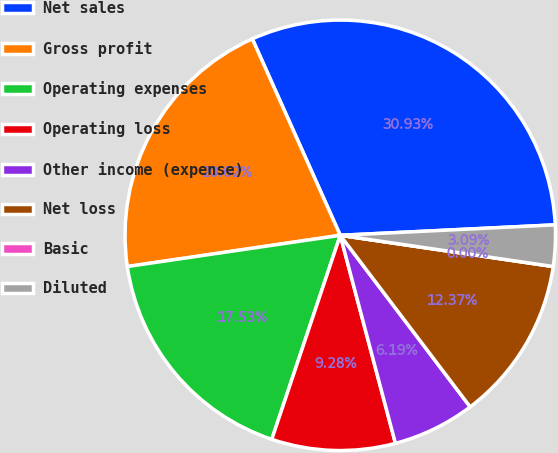<chart> <loc_0><loc_0><loc_500><loc_500><pie_chart><fcel>Net sales<fcel>Gross profit<fcel>Operating expenses<fcel>Operating loss<fcel>Other income (expense)<fcel>Net loss<fcel>Basic<fcel>Diluted<nl><fcel>30.93%<fcel>20.62%<fcel>17.53%<fcel>9.28%<fcel>6.19%<fcel>12.37%<fcel>0.0%<fcel>3.09%<nl></chart> 